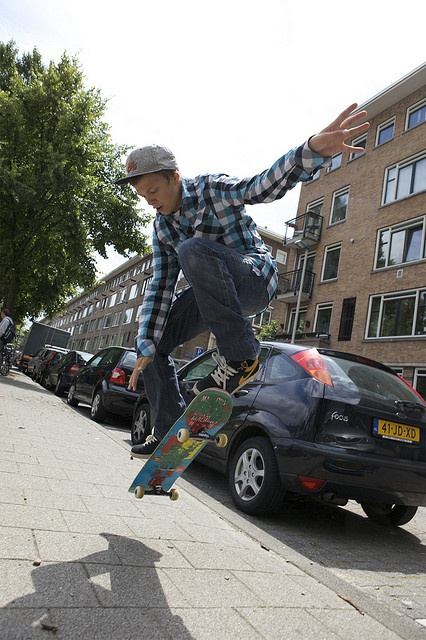Describe the objects in this image and their specific colors. I can see car in lavender, black, gray, and darkgray tones, people in lavender, black, gray, and darkgray tones, skateboard in lavender, gray, teal, darkgreen, and maroon tones, car in lavender, black, gray, darkgray, and maroon tones, and car in lavender, black, gray, lightgray, and maroon tones in this image. 